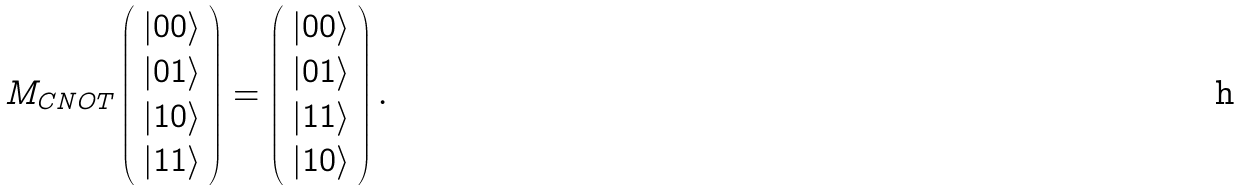Convert formula to latex. <formula><loc_0><loc_0><loc_500><loc_500>M _ { C N O T } \left ( \begin{array} { c } | 0 0 \rangle \\ | 0 1 \rangle \\ | 1 0 \rangle \\ | 1 1 \rangle \end{array} \right ) = \left ( \begin{array} { c } | 0 0 \rangle \\ | 0 1 \rangle \\ | 1 1 \rangle \\ | 1 0 \rangle \end{array} \right ) .</formula> 